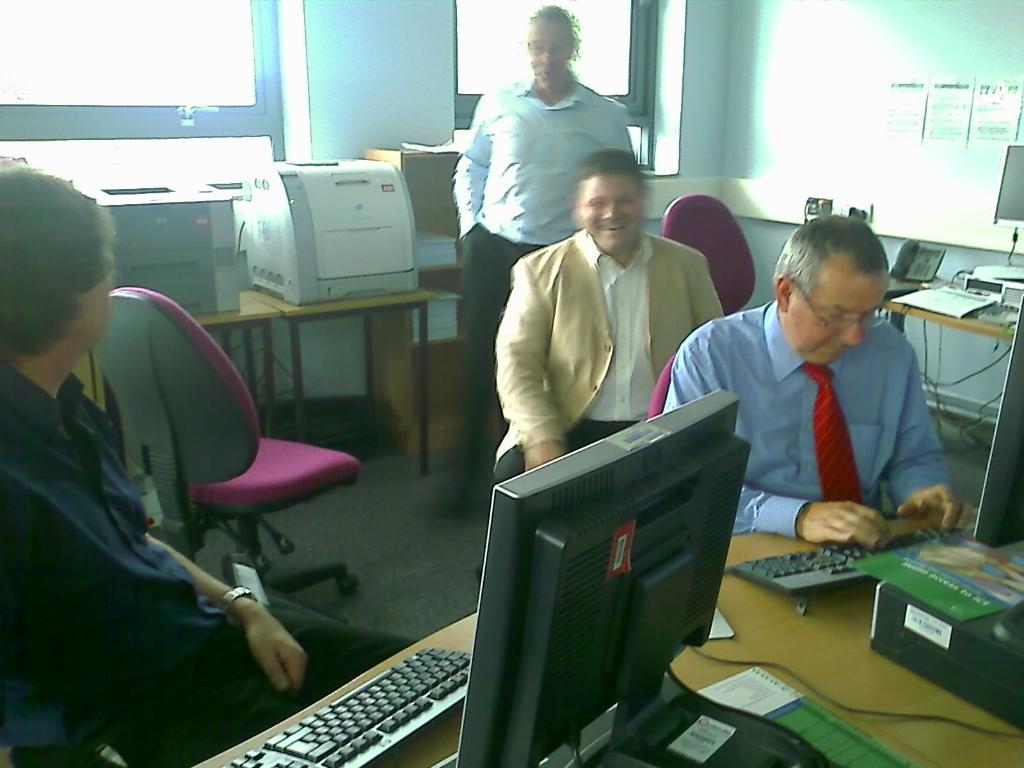How many men are present in the image? There are three men sitting and one man standing in the image. What are the men doing in the image? The men are sitting or standing in the image. What type of furniture is present in the image? There is a chair and a table in the image. What kind of system can be seen in the image? There is a system (possibly a computer or audio system) in the image. What type of leather is used to make the foot of the scissors in the image? There are no scissors or leather present in the image. How many feet are visible in the image? The number of feet visible in the image cannot be determined from the provided facts. 